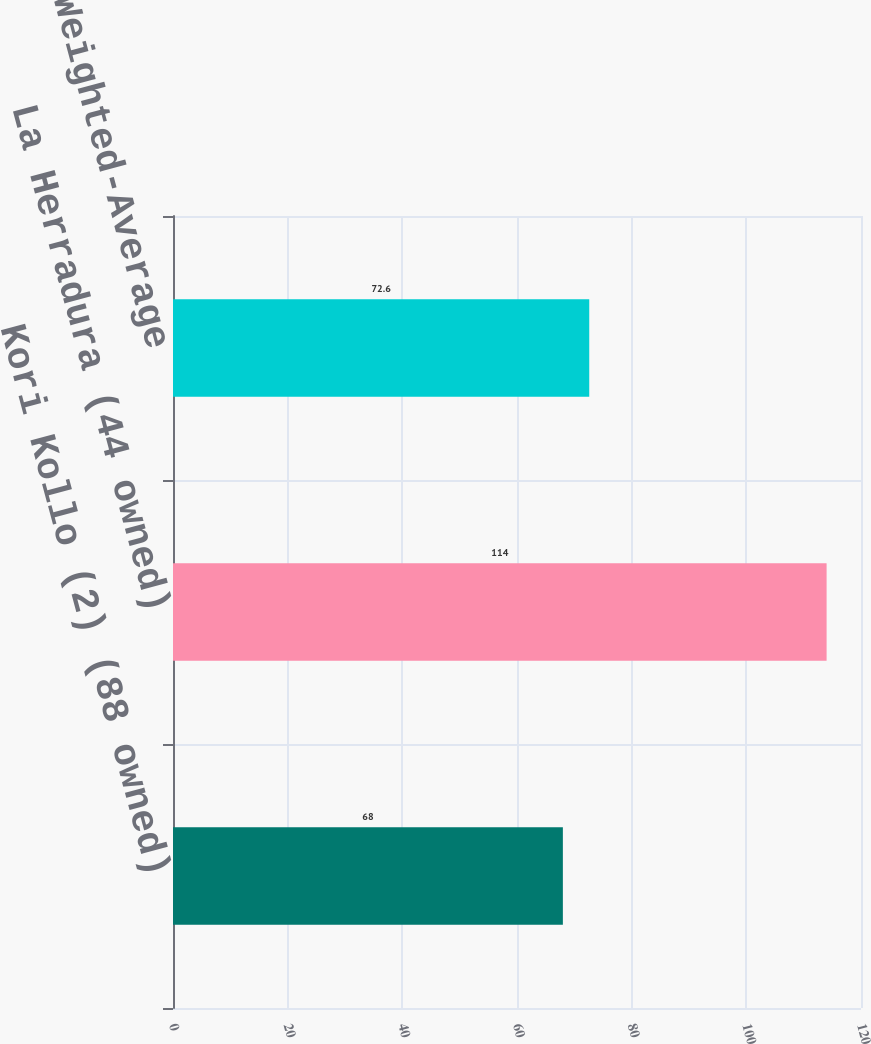Convert chart to OTSL. <chart><loc_0><loc_0><loc_500><loc_500><bar_chart><fcel>Kori Kollo (2) (88 owned)<fcel>La Herradura (44 owned)<fcel>Total/Weighted-Average<nl><fcel>68<fcel>114<fcel>72.6<nl></chart> 